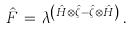Convert formula to latex. <formula><loc_0><loc_0><loc_500><loc_500>\hat { F } \, = \, \lambda ^ { \left ( \hat { H } \otimes \hat { \zeta } - \hat { \zeta } \otimes \hat { H } \right ) } \, .</formula> 